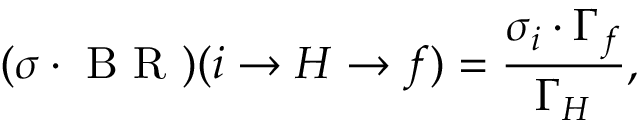<formula> <loc_0><loc_0><loc_500><loc_500>( \sigma \cdot B R ) ( i \to { H } \to f ) = \frac { \sigma _ { i } \cdot \Gamma _ { f } } { \Gamma _ { H } } ,</formula> 